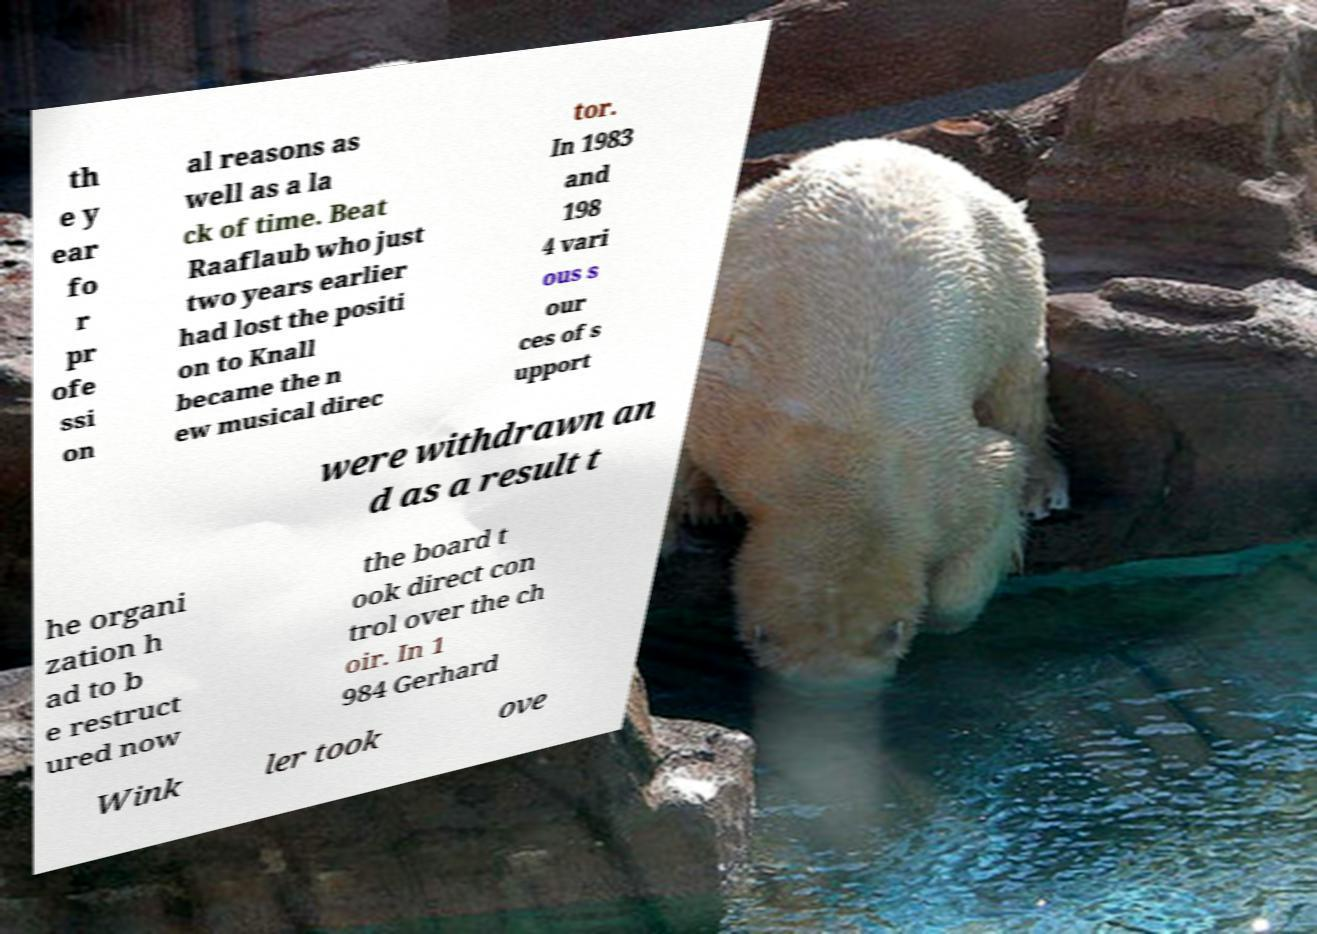What messages or text are displayed in this image? I need them in a readable, typed format. th e y ear fo r pr ofe ssi on al reasons as well as a la ck of time. Beat Raaflaub who just two years earlier had lost the positi on to Knall became the n ew musical direc tor. In 1983 and 198 4 vari ous s our ces of s upport were withdrawn an d as a result t he organi zation h ad to b e restruct ured now the board t ook direct con trol over the ch oir. In 1 984 Gerhard Wink ler took ove 